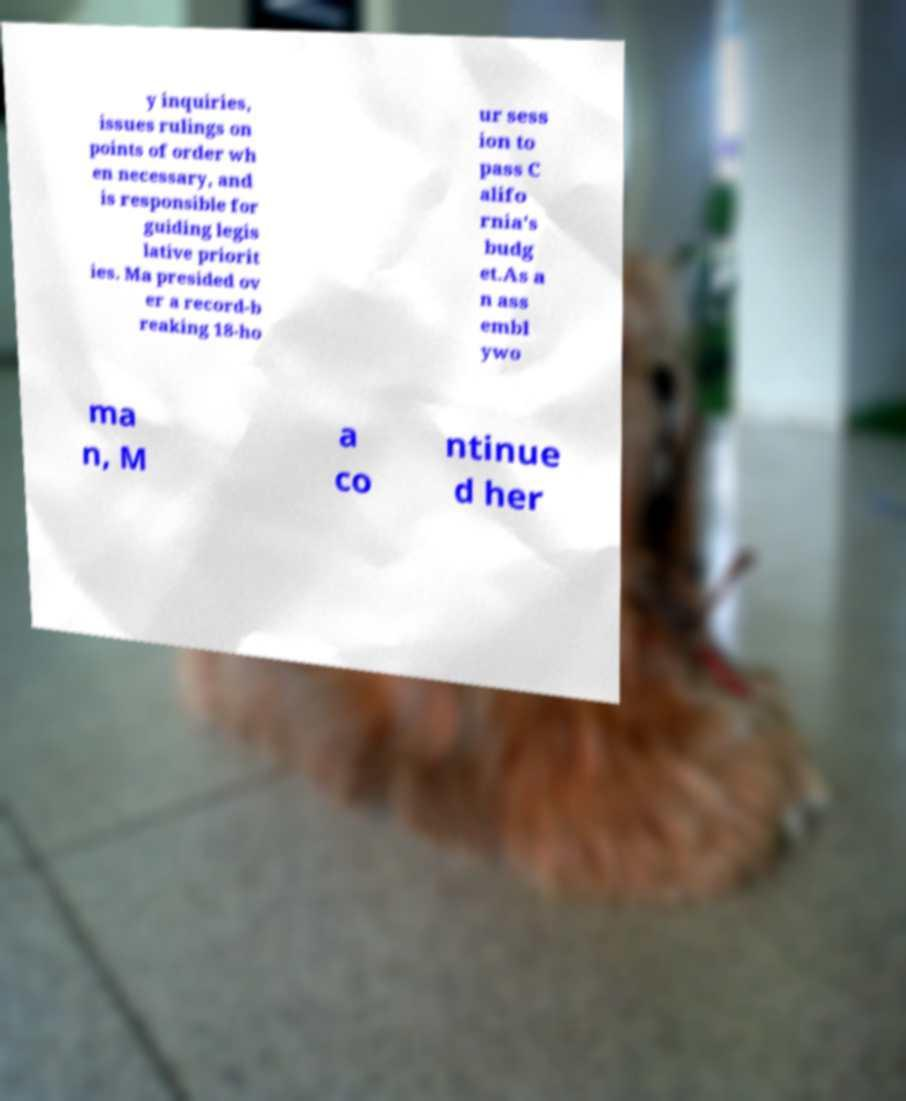There's text embedded in this image that I need extracted. Can you transcribe it verbatim? y inquiries, issues rulings on points of order wh en necessary, and is responsible for guiding legis lative priorit ies. Ma presided ov er a record-b reaking 18-ho ur sess ion to pass C alifo rnia's budg et.As a n ass embl ywo ma n, M a co ntinue d her 